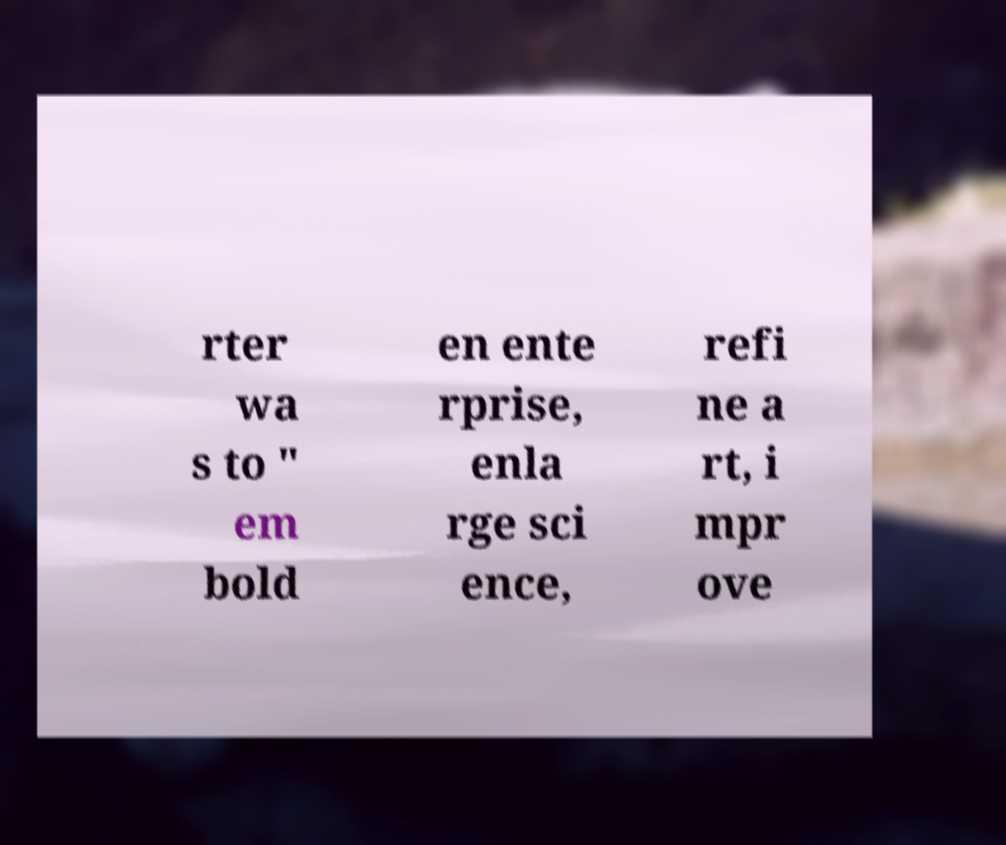Can you read and provide the text displayed in the image?This photo seems to have some interesting text. Can you extract and type it out for me? rter wa s to " em bold en ente rprise, enla rge sci ence, refi ne a rt, i mpr ove 